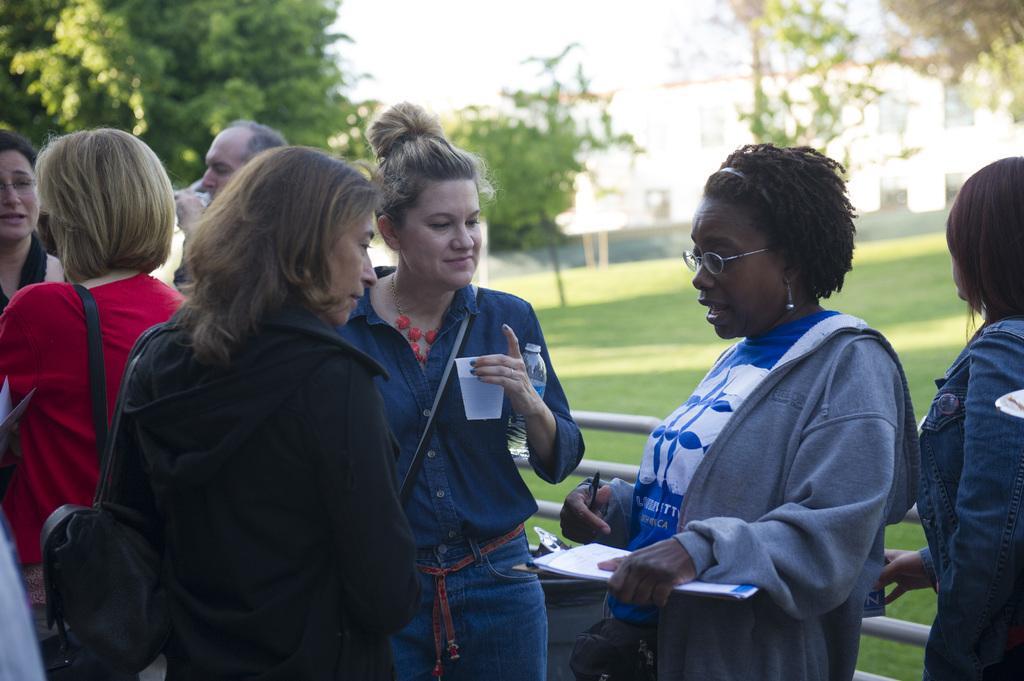Could you give a brief overview of what you see in this image? Here I can see few people are standing and wearing bags. On the right side there is a woman wearing a jacket, holding some papers, a pen in the hand and speaking. Beside her there is another woman holding a bottle and a glass in the hand and looking at this woman. At the back of these people there is a railing. In the background, I can see the grass on the ground and trees. In the background there is a building. At the top of the image I can see the sky. 